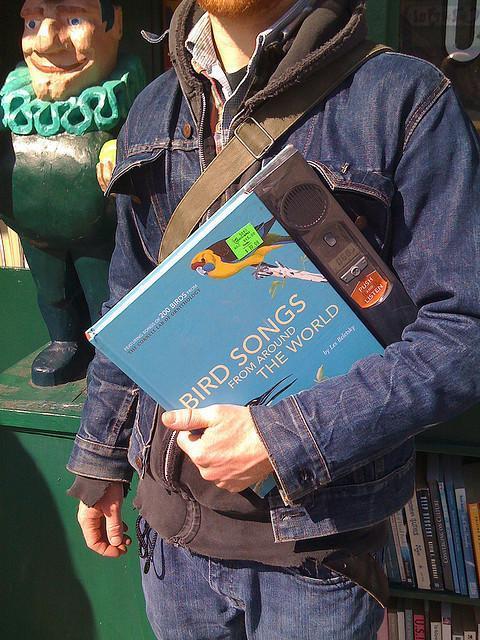How many people are there?
Give a very brief answer. 1. How many backpacks are in the photo?
Give a very brief answer. 1. How many books are visible?
Give a very brief answer. 2. 